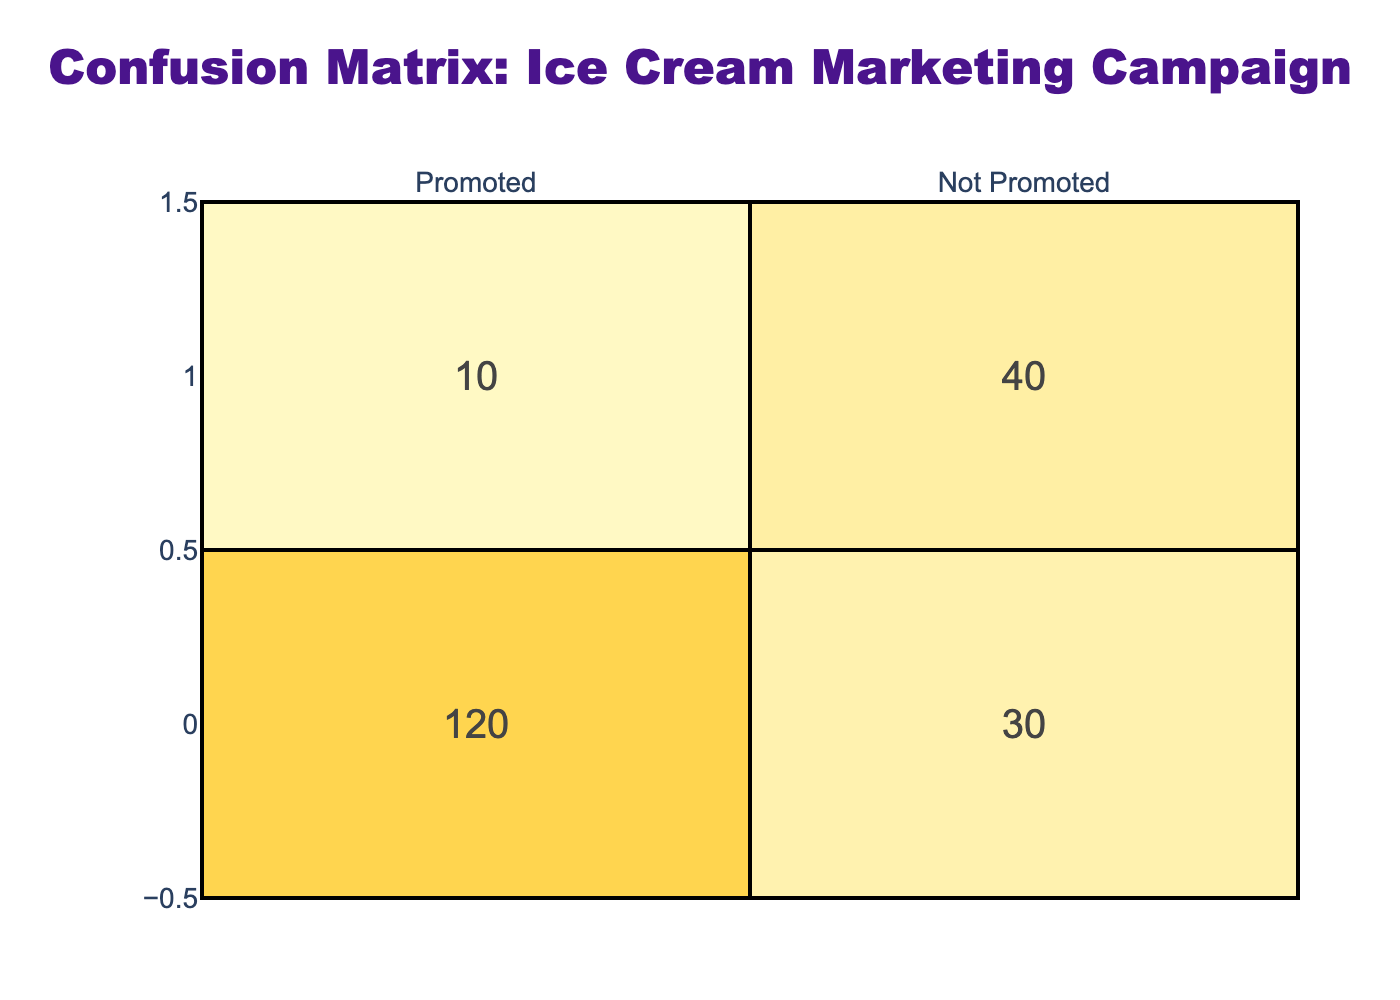What is the total number of people who purchased the ice cream after promotion? According to the table, under the "Purchased" row and "Promoted" column, there are 120 people who bought the ice cream after it was promoted.
Answer: 120 What is the number of people who purchased the ice cream without any promotion? In the "Purchased" row and "Not Promoted" column, the value is 30. This means that 30 people bought ice cream without a promotion.
Answer: 30 How many total purchases were made as a result of the promotion (including both promoted and non-promoted)? To find the total purchases, I need to add both the "Purchased" values under "Promoted" and "Not Promoted": 120 (promoted) + 30 (not promoted) = 150 total purchases.
Answer: 150 How many people did not purchase the ice cream after being promoted? Under the "Not Purchased" row and "Promoted" column, there are 10 individuals. This indicates that 10 people saw the promotion but did not buy the ice cream.
Answer: 10 Is it true that more people purchased ice cream when it was promoted compared to when it was not promoted? The table shows that 120 people purchased the ice cream when promoted, while only 30 purchased it when not promoted. Thus, it is true that more people purchased ice cream with promotion.
Answer: True What is the ratio of people who purchased after promotion to those who did not purchase after promotion? The number of people who purchased after promotion is 120 and the number of those who did not purchase after promotion is 10. The ratio is calculated as 120:10, which simplifies to 12:1.
Answer: 12:1 How many total people did not purchase the ice cream regardless of promotion status? The total number of people who did not purchase includes both values from the "Not Purchased" row: 10 (promoted) + 40 (not promoted) = 50 total people who did not purchase ice cream.
Answer: 50 What percentage of those who saw the promotion actually made a purchase? To find this percentage, I need to calculate how many purchased after promotion (120) out of the total who were promoted (120 + 10 = 130). The percentage is (120/130) * 100, which is approximately 92.31%.
Answer: 92.31% How many more purchases were made with promotion compared to non-promotion? The number of purchases with promotion is 120, and those made without promotion is 30. The difference is 120 - 30 = 90 more purchases made with promotion.
Answer: 90 